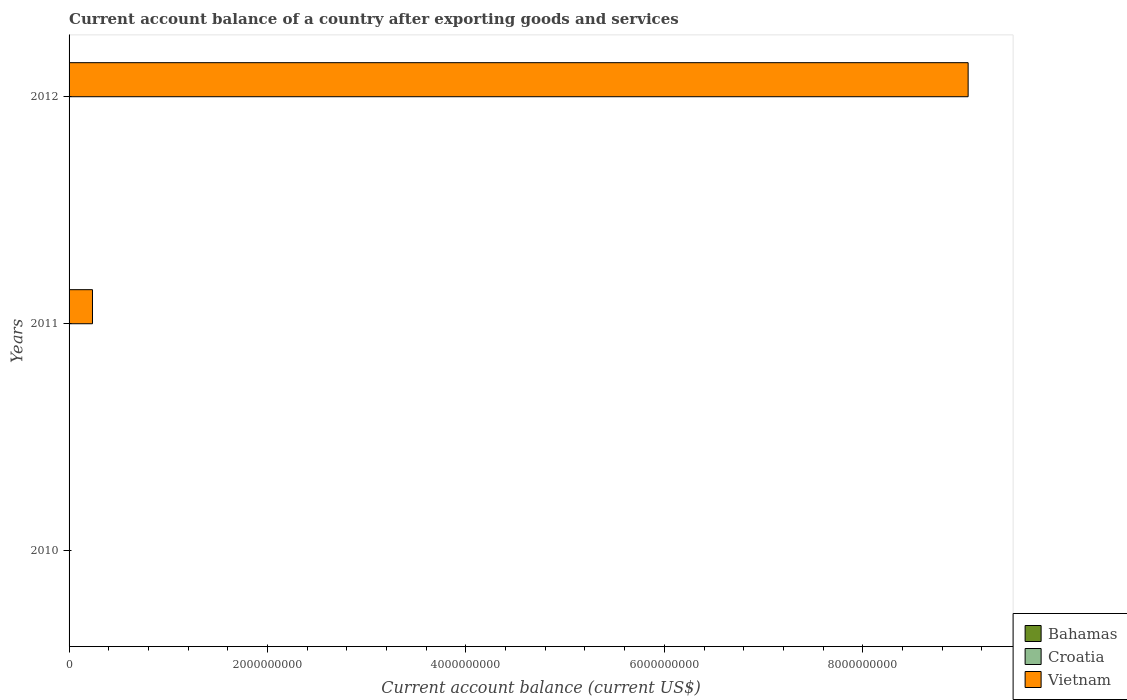How many different coloured bars are there?
Your answer should be very brief. 1. Are the number of bars on each tick of the Y-axis equal?
Provide a short and direct response. No. How many bars are there on the 1st tick from the top?
Offer a terse response. 1. What is the label of the 1st group of bars from the top?
Ensure brevity in your answer.  2012. What is the account balance in Bahamas in 2011?
Your answer should be very brief. 0. Across all years, what is the maximum account balance in Vietnam?
Your response must be concise. 9.06e+09. What is the difference between the account balance in Vietnam in 2011 and that in 2012?
Offer a terse response. -8.83e+09. What is the difference between the account balance in Bahamas in 2010 and the account balance in Croatia in 2011?
Your answer should be very brief. 0. What is the average account balance in Vietnam per year?
Make the answer very short. 3.10e+09. In how many years, is the account balance in Bahamas greater than 4000000000 US$?
Your response must be concise. 0. What is the ratio of the account balance in Vietnam in 2011 to that in 2012?
Offer a terse response. 0.03. What is the difference between the highest and the lowest account balance in Vietnam?
Provide a succinct answer. 9.06e+09. In how many years, is the account balance in Bahamas greater than the average account balance in Bahamas taken over all years?
Your response must be concise. 0. How many bars are there?
Make the answer very short. 2. Are all the bars in the graph horizontal?
Offer a very short reply. Yes. What is the difference between two consecutive major ticks on the X-axis?
Give a very brief answer. 2.00e+09. Are the values on the major ticks of X-axis written in scientific E-notation?
Your answer should be compact. No. Where does the legend appear in the graph?
Keep it short and to the point. Bottom right. How many legend labels are there?
Give a very brief answer. 3. What is the title of the graph?
Your response must be concise. Current account balance of a country after exporting goods and services. Does "Norway" appear as one of the legend labels in the graph?
Ensure brevity in your answer.  No. What is the label or title of the X-axis?
Offer a very short reply. Current account balance (current US$). What is the Current account balance (current US$) of Bahamas in 2010?
Your response must be concise. 0. What is the Current account balance (current US$) of Croatia in 2010?
Offer a terse response. 0. What is the Current account balance (current US$) of Vietnam in 2011?
Offer a very short reply. 2.36e+08. What is the Current account balance (current US$) in Vietnam in 2012?
Ensure brevity in your answer.  9.06e+09. Across all years, what is the maximum Current account balance (current US$) in Vietnam?
Offer a terse response. 9.06e+09. What is the total Current account balance (current US$) of Croatia in the graph?
Make the answer very short. 0. What is the total Current account balance (current US$) in Vietnam in the graph?
Offer a terse response. 9.30e+09. What is the difference between the Current account balance (current US$) in Vietnam in 2011 and that in 2012?
Offer a very short reply. -8.83e+09. What is the average Current account balance (current US$) of Bahamas per year?
Your response must be concise. 0. What is the average Current account balance (current US$) in Vietnam per year?
Offer a terse response. 3.10e+09. What is the ratio of the Current account balance (current US$) of Vietnam in 2011 to that in 2012?
Provide a short and direct response. 0.03. What is the difference between the highest and the lowest Current account balance (current US$) in Vietnam?
Provide a succinct answer. 9.06e+09. 